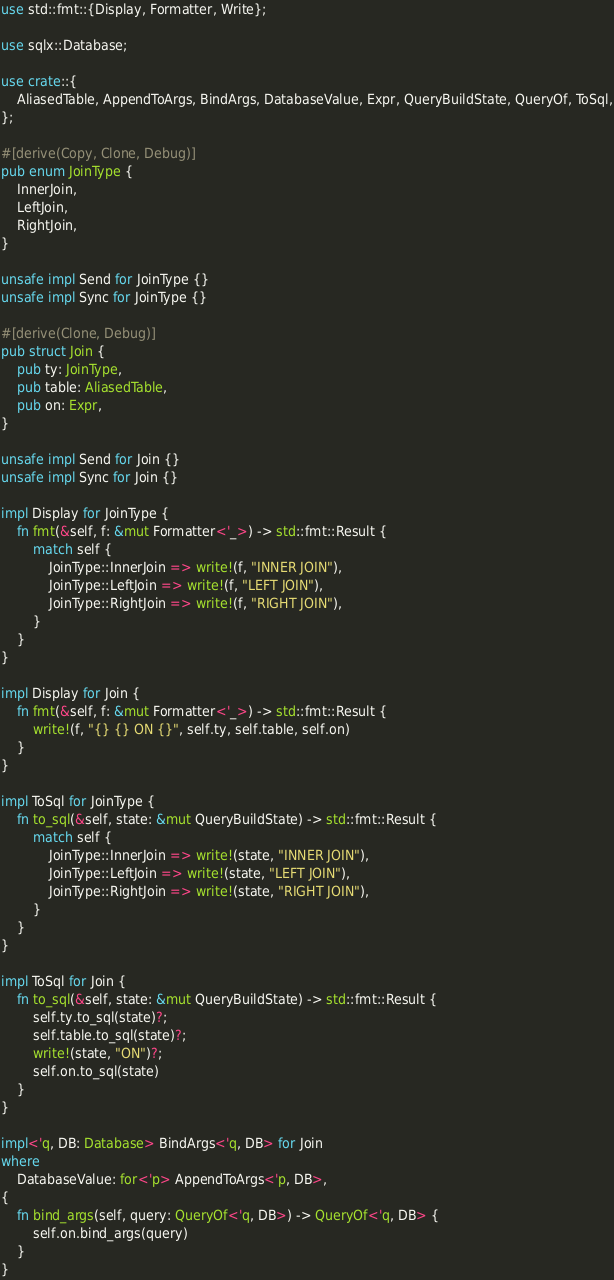Convert code to text. <code><loc_0><loc_0><loc_500><loc_500><_Rust_>use std::fmt::{Display, Formatter, Write};

use sqlx::Database;

use crate::{
    AliasedTable, AppendToArgs, BindArgs, DatabaseValue, Expr, QueryBuildState, QueryOf, ToSql,
};

#[derive(Copy, Clone, Debug)]
pub enum JoinType {
    InnerJoin,
    LeftJoin,
    RightJoin,
}

unsafe impl Send for JoinType {}
unsafe impl Sync for JoinType {}

#[derive(Clone, Debug)]
pub struct Join {
    pub ty: JoinType,
    pub table: AliasedTable,
    pub on: Expr,
}

unsafe impl Send for Join {}
unsafe impl Sync for Join {}

impl Display for JoinType {
    fn fmt(&self, f: &mut Formatter<'_>) -> std::fmt::Result {
        match self {
            JoinType::InnerJoin => write!(f, "INNER JOIN"),
            JoinType::LeftJoin => write!(f, "LEFT JOIN"),
            JoinType::RightJoin => write!(f, "RIGHT JOIN"),
        }
    }
}

impl Display for Join {
    fn fmt(&self, f: &mut Formatter<'_>) -> std::fmt::Result {
        write!(f, "{} {} ON {}", self.ty, self.table, self.on)
    }
}

impl ToSql for JoinType {
    fn to_sql(&self, state: &mut QueryBuildState) -> std::fmt::Result {
        match self {
            JoinType::InnerJoin => write!(state, "INNER JOIN"),
            JoinType::LeftJoin => write!(state, "LEFT JOIN"),
            JoinType::RightJoin => write!(state, "RIGHT JOIN"),
        }
    }
}

impl ToSql for Join {
    fn to_sql(&self, state: &mut QueryBuildState) -> std::fmt::Result {
        self.ty.to_sql(state)?;
        self.table.to_sql(state)?;
        write!(state, "ON")?;
        self.on.to_sql(state)
    }
}

impl<'q, DB: Database> BindArgs<'q, DB> for Join
where
    DatabaseValue: for<'p> AppendToArgs<'p, DB>,
{
    fn bind_args(self, query: QueryOf<'q, DB>) -> QueryOf<'q, DB> {
        self.on.bind_args(query)
    }
}
</code> 